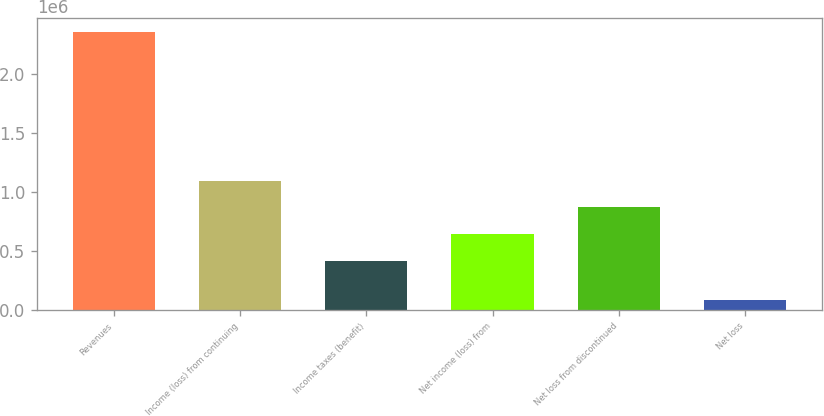Convert chart. <chart><loc_0><loc_0><loc_500><loc_500><bar_chart><fcel>Revenues<fcel>Income (loss) from continuing<fcel>Income taxes (benefit)<fcel>Net income (loss) from<fcel>Net loss from discontinued<fcel>Net loss<nl><fcel>2.35124e+06<fcel>1.09474e+06<fcel>415037<fcel>641605<fcel>868173<fcel>85564<nl></chart> 